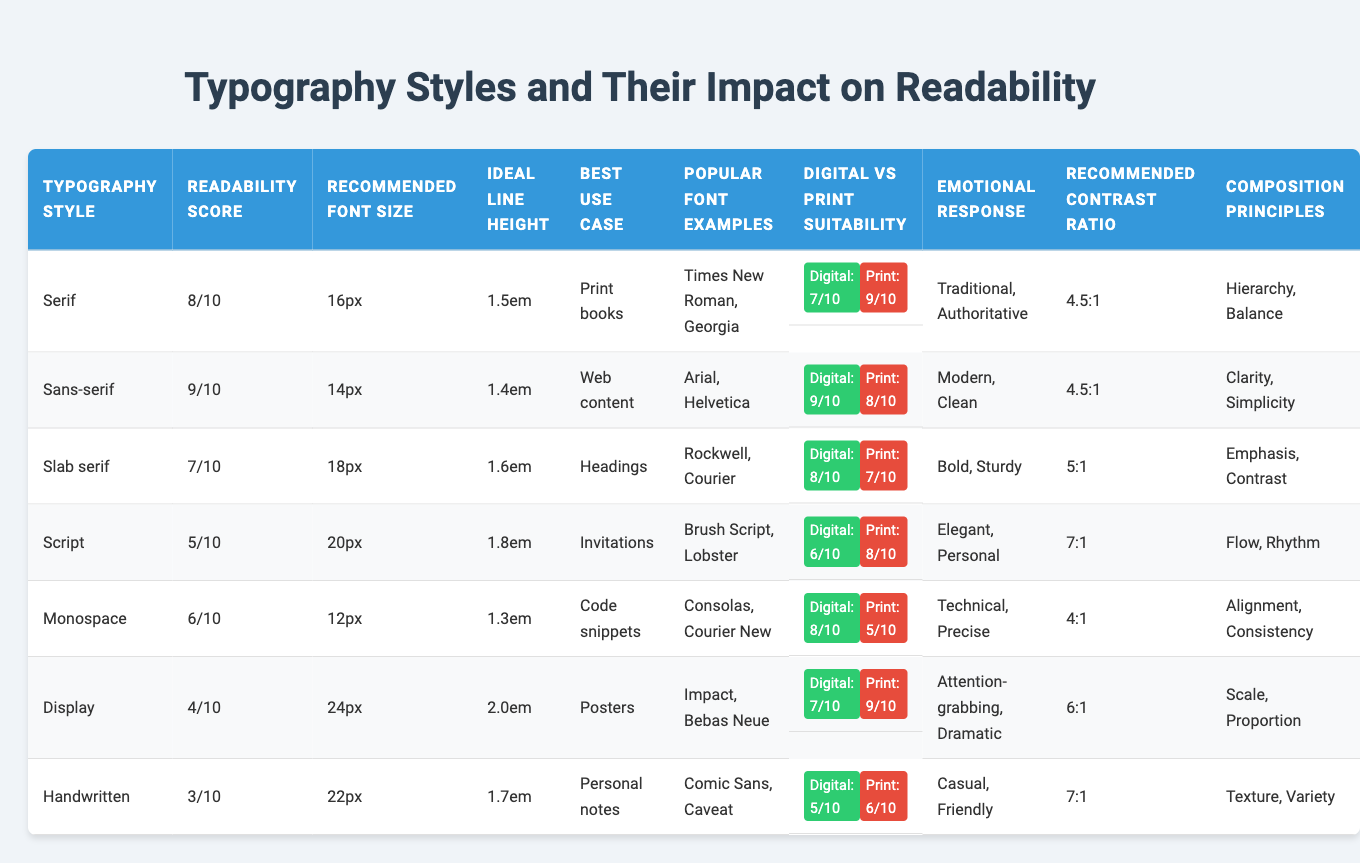What is the highest readability score among the typography styles? The highest readability score in the table is 9, corresponding to the Sans-serif style.
Answer: 9 Which typography style is best suited for invitations? The table indicates that Script typography is best suited for invitations.
Answer: Script What is the recommended font size for Slab serif typography? The table shows that the recommended font size for Slab serif typography is 18px.
Answer: 18px What is the emotional response associated with Monospace typography? According to the table, the emotional response for Monospace typography is "Technical, Precise."
Answer: Technical, Precise Which typography style has the lowest digital suitability score? The Digital suitability score for Handwritten typography is 5, which is the lowest among all styles listed.
Answer: 5 What is the average readability score of all the typography styles? The total readability score is 8 + 9 + 7 + 5 + 6 + 4 + 3 = 42. There are 7 styles, so the average is 42 / 7 = 6.
Answer: 6 Is it true that Display typography has a higher recommended font size than Monospace typography? The table shows that Display typography has a recommended font size of 24px and Monospace typography has 12px, making the statement true.
Answer: Yes Which typography style is most suitable for print, based on the table's ratings? According to the ratings, the Serif style has a print suitability score of 9, making it the most suitable for print.
Answer: Serif What is the recommended contrast ratio for handwritten typography? The table specifies that the recommended contrast ratio for Handwritten typography is 7:1.
Answer: 7:1 Considering readability scores, what can be inferred about the emotional response associated with Script typography? Script typography has a readability score of 5, which suggests it is less readable, indicating that while it evokes an "Elegant, Personal" emotion, it may not be the best for clarity in reading.
Answer: Less readable, "Elegant, Personal" 